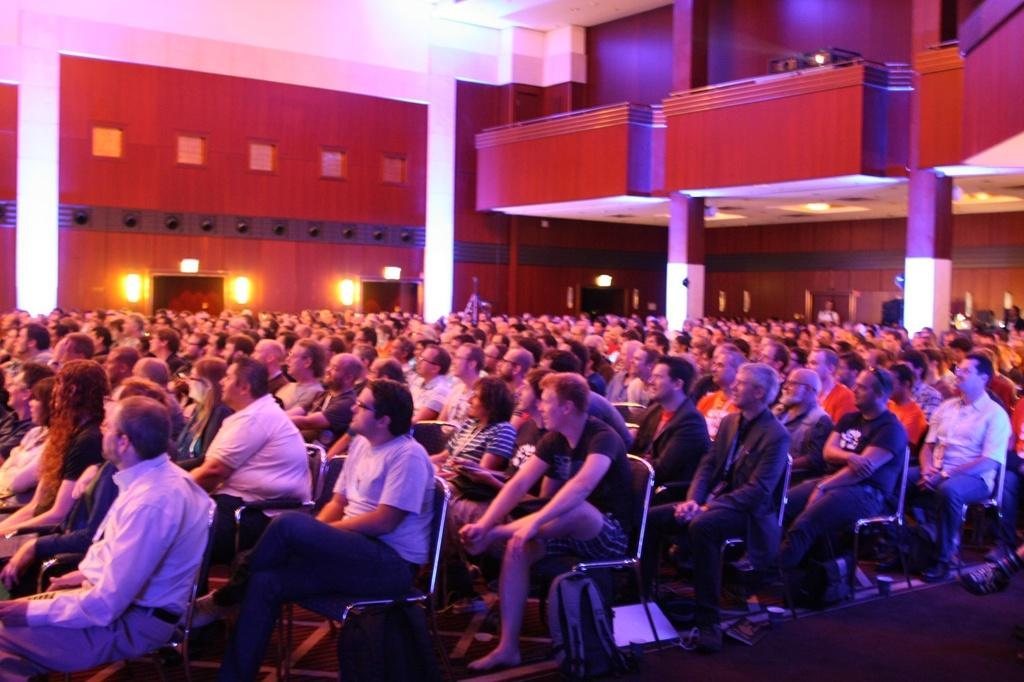Who or what is present in the image? There are people in the image. What are the people doing in the image? The people are sitting on chairs. What can be seen in the distance behind the people? There is a building in the background of the image. Can you see a toad crawling on the chairs in the image? No, there is no toad present in the image. How many snails can be seen on the building in the background? There are no snails visible on the building in the background of the image. 